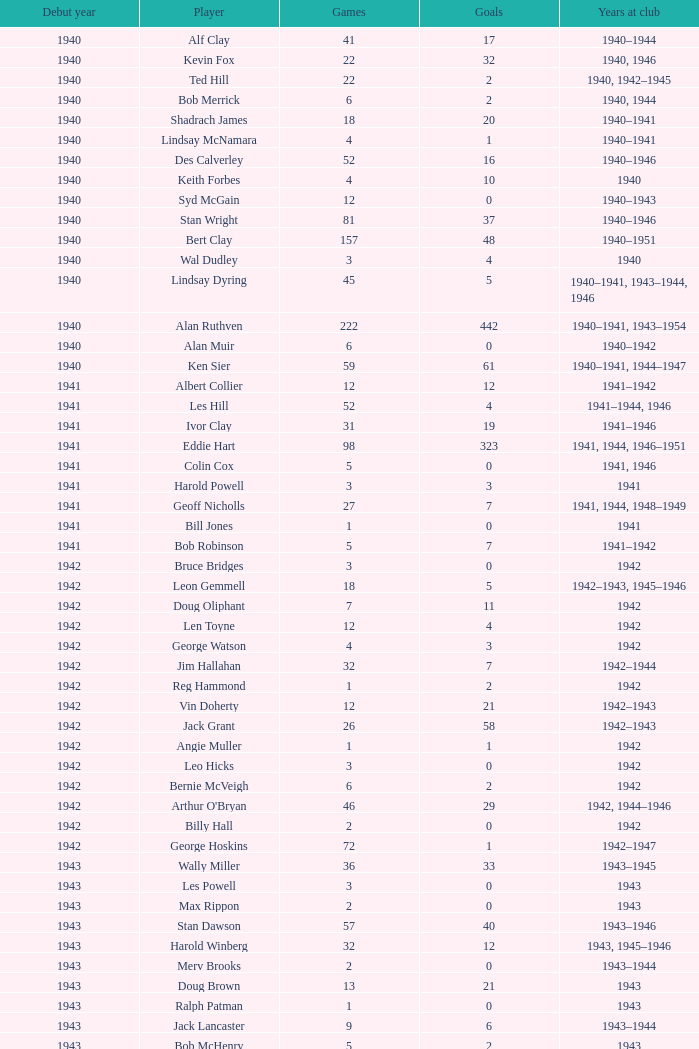Parse the full table. {'header': ['Debut year', 'Player', 'Games', 'Goals', 'Years at club'], 'rows': [['1940', 'Alf Clay', '41', '17', '1940–1944'], ['1940', 'Kevin Fox', '22', '32', '1940, 1946'], ['1940', 'Ted Hill', '22', '2', '1940, 1942–1945'], ['1940', 'Bob Merrick', '6', '2', '1940, 1944'], ['1940', 'Shadrach James', '18', '20', '1940–1941'], ['1940', 'Lindsay McNamara', '4', '1', '1940–1941'], ['1940', 'Des Calverley', '52', '16', '1940–1946'], ['1940', 'Keith Forbes', '4', '10', '1940'], ['1940', 'Syd McGain', '12', '0', '1940–1943'], ['1940', 'Stan Wright', '81', '37', '1940–1946'], ['1940', 'Bert Clay', '157', '48', '1940–1951'], ['1940', 'Wal Dudley', '3', '4', '1940'], ['1940', 'Lindsay Dyring', '45', '5', '1940–1941, 1943–1944, 1946'], ['1940', 'Alan Ruthven', '222', '442', '1940–1941, 1943–1954'], ['1940', 'Alan Muir', '6', '0', '1940–1942'], ['1940', 'Ken Sier', '59', '61', '1940–1941, 1944–1947'], ['1941', 'Albert Collier', '12', '12', '1941–1942'], ['1941', 'Les Hill', '52', '4', '1941–1944, 1946'], ['1941', 'Ivor Clay', '31', '19', '1941–1946'], ['1941', 'Eddie Hart', '98', '323', '1941, 1944, 1946–1951'], ['1941', 'Colin Cox', '5', '0', '1941, 1946'], ['1941', 'Harold Powell', '3', '3', '1941'], ['1941', 'Geoff Nicholls', '27', '7', '1941, 1944, 1948–1949'], ['1941', 'Bill Jones', '1', '0', '1941'], ['1941', 'Bob Robinson', '5', '7', '1941–1942'], ['1942', 'Bruce Bridges', '3', '0', '1942'], ['1942', 'Leon Gemmell', '18', '5', '1942–1943, 1945–1946'], ['1942', 'Doug Oliphant', '7', '11', '1942'], ['1942', 'Len Toyne', '12', '4', '1942'], ['1942', 'George Watson', '4', '3', '1942'], ['1942', 'Jim Hallahan', '32', '7', '1942–1944'], ['1942', 'Reg Hammond', '1', '2', '1942'], ['1942', 'Vin Doherty', '12', '21', '1942–1943'], ['1942', 'Jack Grant', '26', '58', '1942–1943'], ['1942', 'Angie Muller', '1', '1', '1942'], ['1942', 'Leo Hicks', '3', '0', '1942'], ['1942', 'Bernie McVeigh', '6', '2', '1942'], ['1942', "Arthur O'Bryan", '46', '29', '1942, 1944–1946'], ['1942', 'Billy Hall', '2', '0', '1942'], ['1942', 'George Hoskins', '72', '1', '1942–1947'], ['1943', 'Wally Miller', '36', '33', '1943–1945'], ['1943', 'Les Powell', '3', '0', '1943'], ['1943', 'Max Rippon', '2', '0', '1943'], ['1943', 'Stan Dawson', '57', '40', '1943–1946'], ['1943', 'Harold Winberg', '32', '12', '1943, 1945–1946'], ['1943', 'Merv Brooks', '2', '0', '1943–1944'], ['1943', 'Doug Brown', '13', '21', '1943'], ['1943', 'Ralph Patman', '1', '0', '1943'], ['1943', 'Jack Lancaster', '9', '6', '1943–1944'], ['1943', 'Bob McHenry', '5', '2', '1943'], ['1943', 'Ted Tomkins', '1', '0', '1943'], ['1943', 'Bernie Fyffe', '2', '3', '1943'], ['1943', 'Monty Horan', '21', '1', '1943–1946'], ['1943', 'Adrian Hearn', '3', '1', '1943'], ['1943', 'Dennis Hall', '5', '0', '1943–1945'], ['1943', 'Bill Spokes', '5', '3', '1943–1944'], ['1944', 'Billy Walsh', '1', '0', '1944'], ['1944', 'Wally Bristowe', '18', '14', '1944–1945'], ['1944', 'Laurie Bickerton', '12', '0', '1944'], ['1944', 'Charlie Linney', '12', '0', '1944–1946'], ['1944', 'Jack Harrow', '2', '0', '1944'], ['1944', 'Noel Jarvis', '159', '31', '1944–1952'], ['1944', 'Norm Johnstone', '228', '185', '1944–1957'], ['1944', 'Jack Symons', '36', '58', '1944–1946'], ['1945', 'Laurie Crouch', '8', '4', '1945–1946'], ['1945', 'Jack Collins', '31', '36', '1945–1949'], ['1945', 'Jim Kettle', '41', '23', '1945, 1947–1952'], ['1945', 'Peter Dalwood', '7', '12', '1945'], ['1945', 'Ed White', '1', '0', '1945'], ['1945', 'Don Hammond', '5', '0', '1945'], ['1945', 'Harold Shillinglaw', '63', '19', '1945–1951'], ['1945', 'Jim Brown', '10', '5', '1945, 1947'], ['1946', 'Alan McLaughlin', '76', '6', '1946–1950'], ['1946', 'Merv Smith', '9', '0', '1946–1948'], ['1946', 'Vic Chanter', '108', '0', '1946–1952'], ['1946', 'Norm Reidy', '1', '0', '1946'], ['1946', 'Reg Nicholls', '83', '3', '1946–1950'], ['1946', 'Bob Miller', '44', '3', '1946–1950'], ['1946', 'Stan Vandersluys', '47', '26', '1946–1952'], ['1946', 'Allan Broadway', '3', '2', '1946'], ['1947', 'Bill Stephen', '162', '4', '1947–1957'], ['1947', 'Don Chipp', '3', '1', '1947'], ['1947', 'George Coates', '128', '128', '1947–1954'], ['1947', 'Heinz Tonn', '6', '2', '1947'], ['1947', 'Dick Kennedy', '63', '47', '1947–1951'], ['1947', "Neil O'Reilly", '1', '0', '1947'], ['1947', 'Jim Toohey', '57', '12', '1947–1949, 1951–1952'], ['1947', 'Llew Owens', '5', '3', '1947'], ['1947', 'Kevin Hart', '19', '8', '1947–1949'], ['1948', 'Ron Kinder', '5', '1', '1948'], ['1948', 'Ken Ross', '129', '36', '1948–1955, 1959–1960'], ['1948', 'Keith Williams', '18', '12', '1948'], ['1948', 'Wal Alexander', '7', '0', '1948'], ['1948', 'Eric Moore', '19', '14', '1948–1950'], ['1948', 'Gerry Sier', '10', '0', '1948–1949'], ['1948', 'Gordon Brunnen', '3', '0', '1948'], ['1948', 'Bill Charleson', '4', '0', '1948'], ['1948', 'Alan Gale', '213', '19', '1948–1961'], ['1949', 'Jack Gaffney', '80', '0', '1949–1953'], ['1949', 'Ron Simpson', '37', '23', '1949–1953'], ['1949', 'Norm Smith', '17', '26', '1949–1950'], ['1949', 'Barry Waters', '1', '0', '1949'], ['1949', 'Ray Donnellan', '40', '0', '1949–1951'], ['1949', 'Jack Streader', '69', '45', '1949–1955'], ['1949', 'Don Furness', '136', '43', '1949–1959'], ['1949', 'Eddie Goodger', '149', '1', '1949–1958'], ['1949', 'Ron Bickley', '29', '0', '1949–1951'], ['1949', 'Ron Wright', '3', '0', '1949'], ['1949', 'Reg Milburn', '2', '0', '1949']]} Which athlete started their career before 1943, was part of the club in 1942, had less than 12 appearances, and netted fewer than 11 goals? Bruce Bridges, George Watson, Reg Hammond, Angie Muller, Leo Hicks, Bernie McVeigh, Billy Hall. 